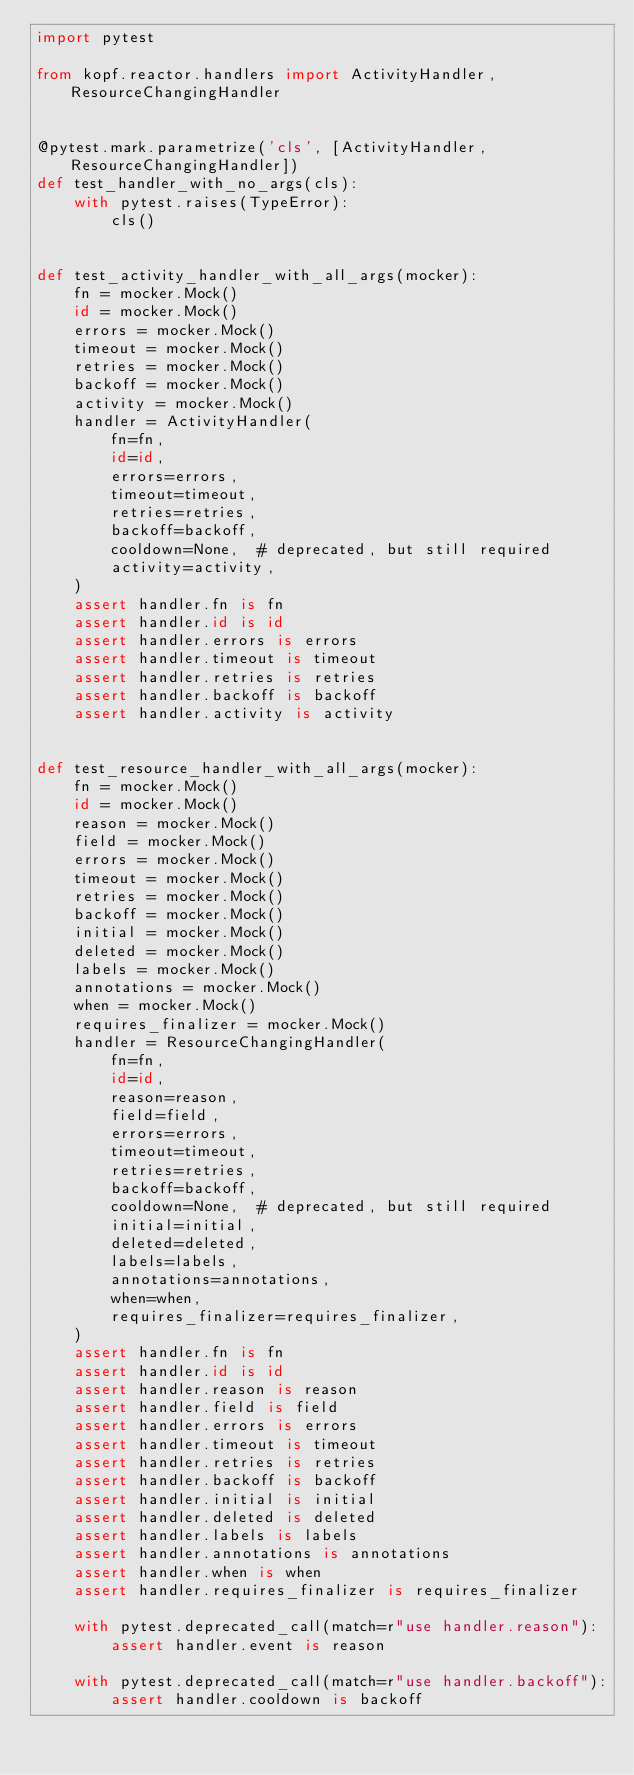<code> <loc_0><loc_0><loc_500><loc_500><_Python_>import pytest

from kopf.reactor.handlers import ActivityHandler, ResourceChangingHandler


@pytest.mark.parametrize('cls', [ActivityHandler, ResourceChangingHandler])
def test_handler_with_no_args(cls):
    with pytest.raises(TypeError):
        cls()


def test_activity_handler_with_all_args(mocker):
    fn = mocker.Mock()
    id = mocker.Mock()
    errors = mocker.Mock()
    timeout = mocker.Mock()
    retries = mocker.Mock()
    backoff = mocker.Mock()
    activity = mocker.Mock()
    handler = ActivityHandler(
        fn=fn,
        id=id,
        errors=errors,
        timeout=timeout,
        retries=retries,
        backoff=backoff,
        cooldown=None,  # deprecated, but still required
        activity=activity,
    )
    assert handler.fn is fn
    assert handler.id is id
    assert handler.errors is errors
    assert handler.timeout is timeout
    assert handler.retries is retries
    assert handler.backoff is backoff
    assert handler.activity is activity


def test_resource_handler_with_all_args(mocker):
    fn = mocker.Mock()
    id = mocker.Mock()
    reason = mocker.Mock()
    field = mocker.Mock()
    errors = mocker.Mock()
    timeout = mocker.Mock()
    retries = mocker.Mock()
    backoff = mocker.Mock()
    initial = mocker.Mock()
    deleted = mocker.Mock()
    labels = mocker.Mock()
    annotations = mocker.Mock()
    when = mocker.Mock()
    requires_finalizer = mocker.Mock()
    handler = ResourceChangingHandler(
        fn=fn,
        id=id,
        reason=reason,
        field=field,
        errors=errors,
        timeout=timeout,
        retries=retries,
        backoff=backoff,
        cooldown=None,  # deprecated, but still required
        initial=initial,
        deleted=deleted,
        labels=labels,
        annotations=annotations,
        when=when,
        requires_finalizer=requires_finalizer,
    )
    assert handler.fn is fn
    assert handler.id is id
    assert handler.reason is reason
    assert handler.field is field
    assert handler.errors is errors
    assert handler.timeout is timeout
    assert handler.retries is retries
    assert handler.backoff is backoff
    assert handler.initial is initial
    assert handler.deleted is deleted
    assert handler.labels is labels
    assert handler.annotations is annotations
    assert handler.when is when
    assert handler.requires_finalizer is requires_finalizer

    with pytest.deprecated_call(match=r"use handler.reason"):
        assert handler.event is reason

    with pytest.deprecated_call(match=r"use handler.backoff"):
        assert handler.cooldown is backoff
</code> 